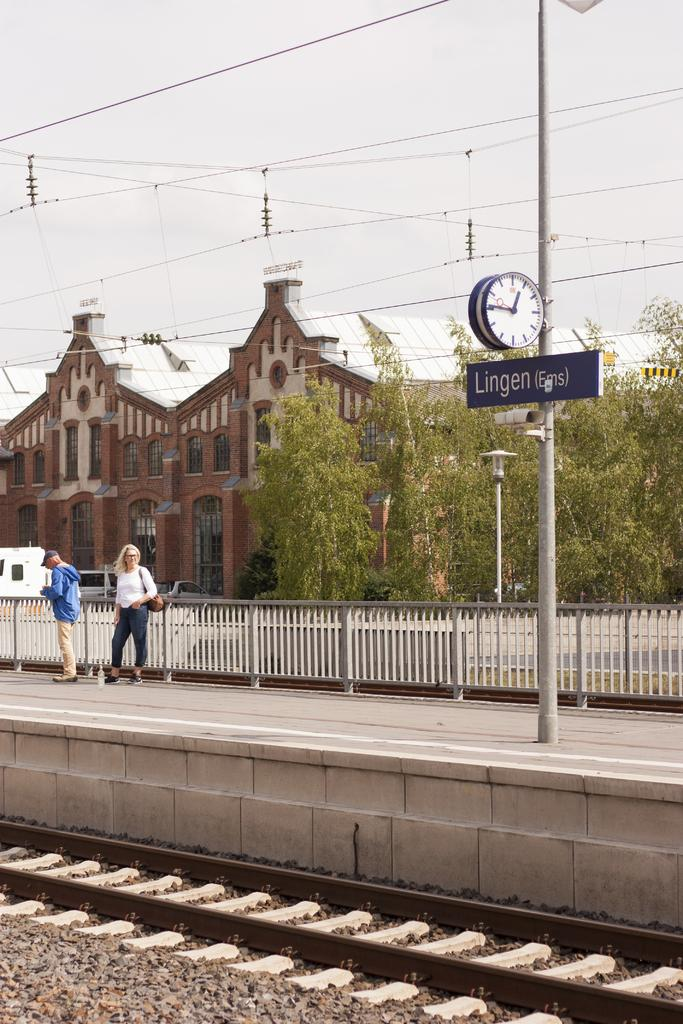<image>
Present a compact description of the photo's key features. Two people waiting at the Lingen train station 